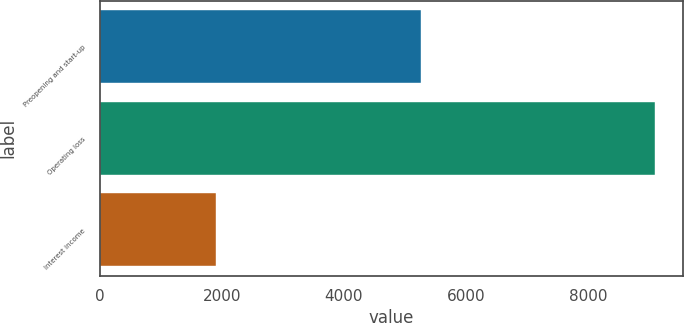Convert chart to OTSL. <chart><loc_0><loc_0><loc_500><loc_500><bar_chart><fcel>Preopening and start-up<fcel>Operating loss<fcel>Interest income<nl><fcel>5258<fcel>9100<fcel>1913<nl></chart> 